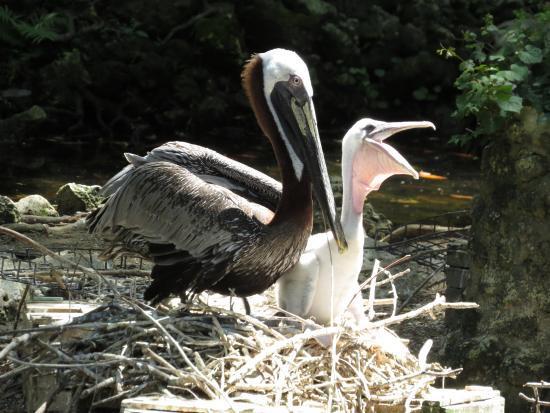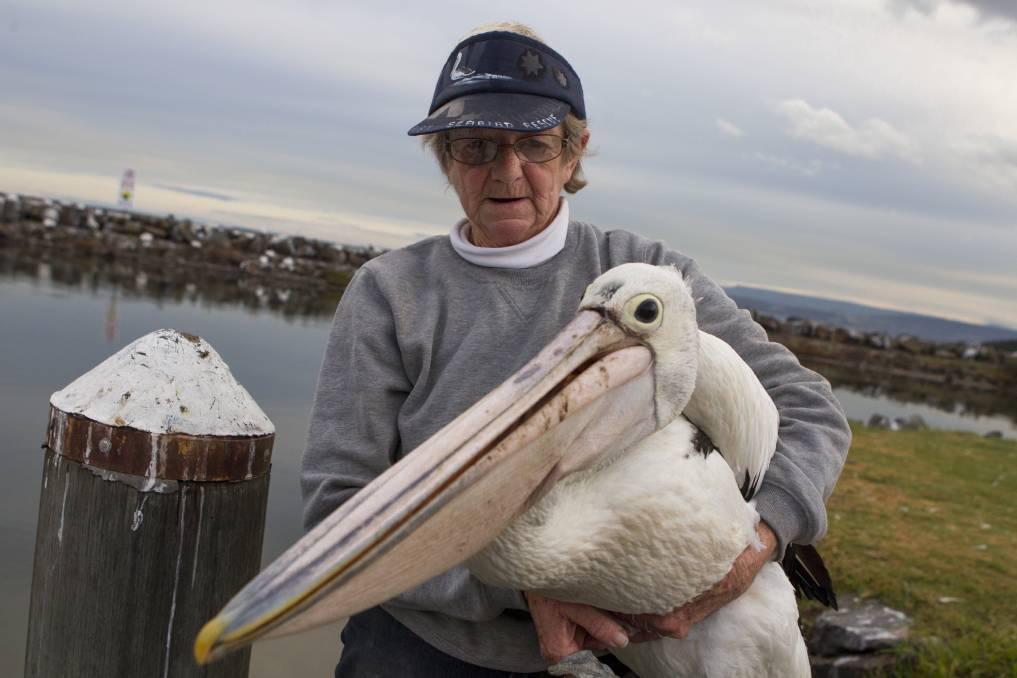The first image is the image on the left, the second image is the image on the right. Given the left and right images, does the statement "Two pelicans in one image with the same feather coloring and design are standing face to face and making contact with their heads." hold true? Answer yes or no. No. The first image is the image on the left, the second image is the image on the right. Analyze the images presented: Is the assertion "An image shows exactly two juvenile pelicans with fuzzy white feathers posed close together." valid? Answer yes or no. No. 